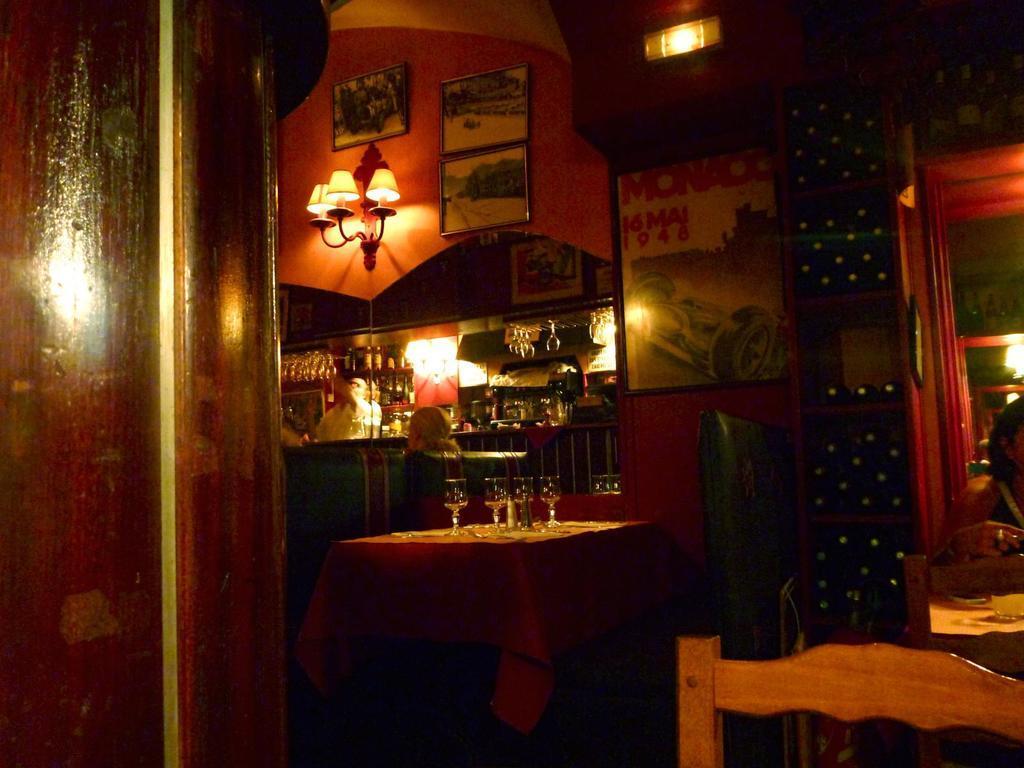Describe this image in one or two sentences. This is clicked in the bar, there are tables with wine bottles and two women sitting in front of it and in the back there are lights on the wall with photographs and below there are wine bottles and glasses on the table with a man standing in front of it. 